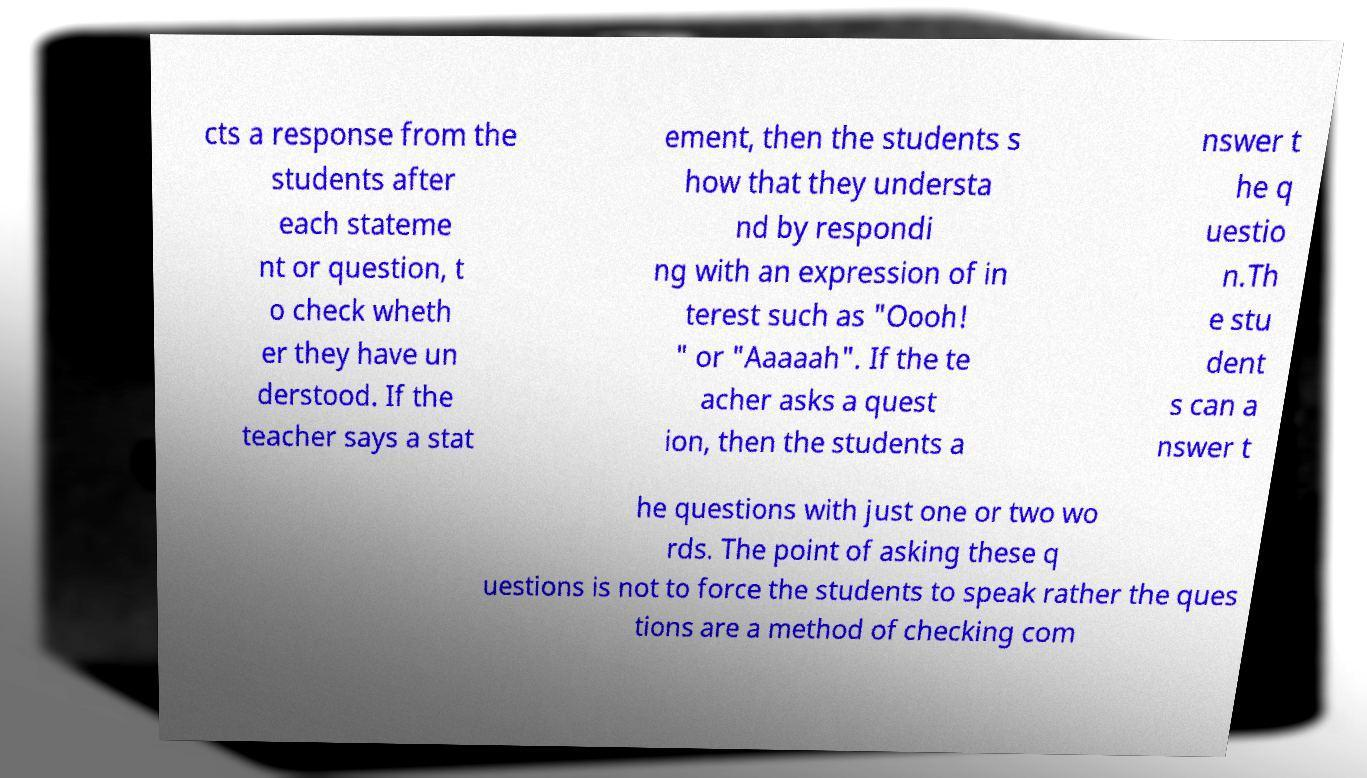Could you extract and type out the text from this image? cts a response from the students after each stateme nt or question, t o check wheth er they have un derstood. If the teacher says a stat ement, then the students s how that they understa nd by respondi ng with an expression of in terest such as "Oooh! " or "Aaaaah". If the te acher asks a quest ion, then the students a nswer t he q uestio n.Th e stu dent s can a nswer t he questions with just one or two wo rds. The point of asking these q uestions is not to force the students to speak rather the ques tions are a method of checking com 